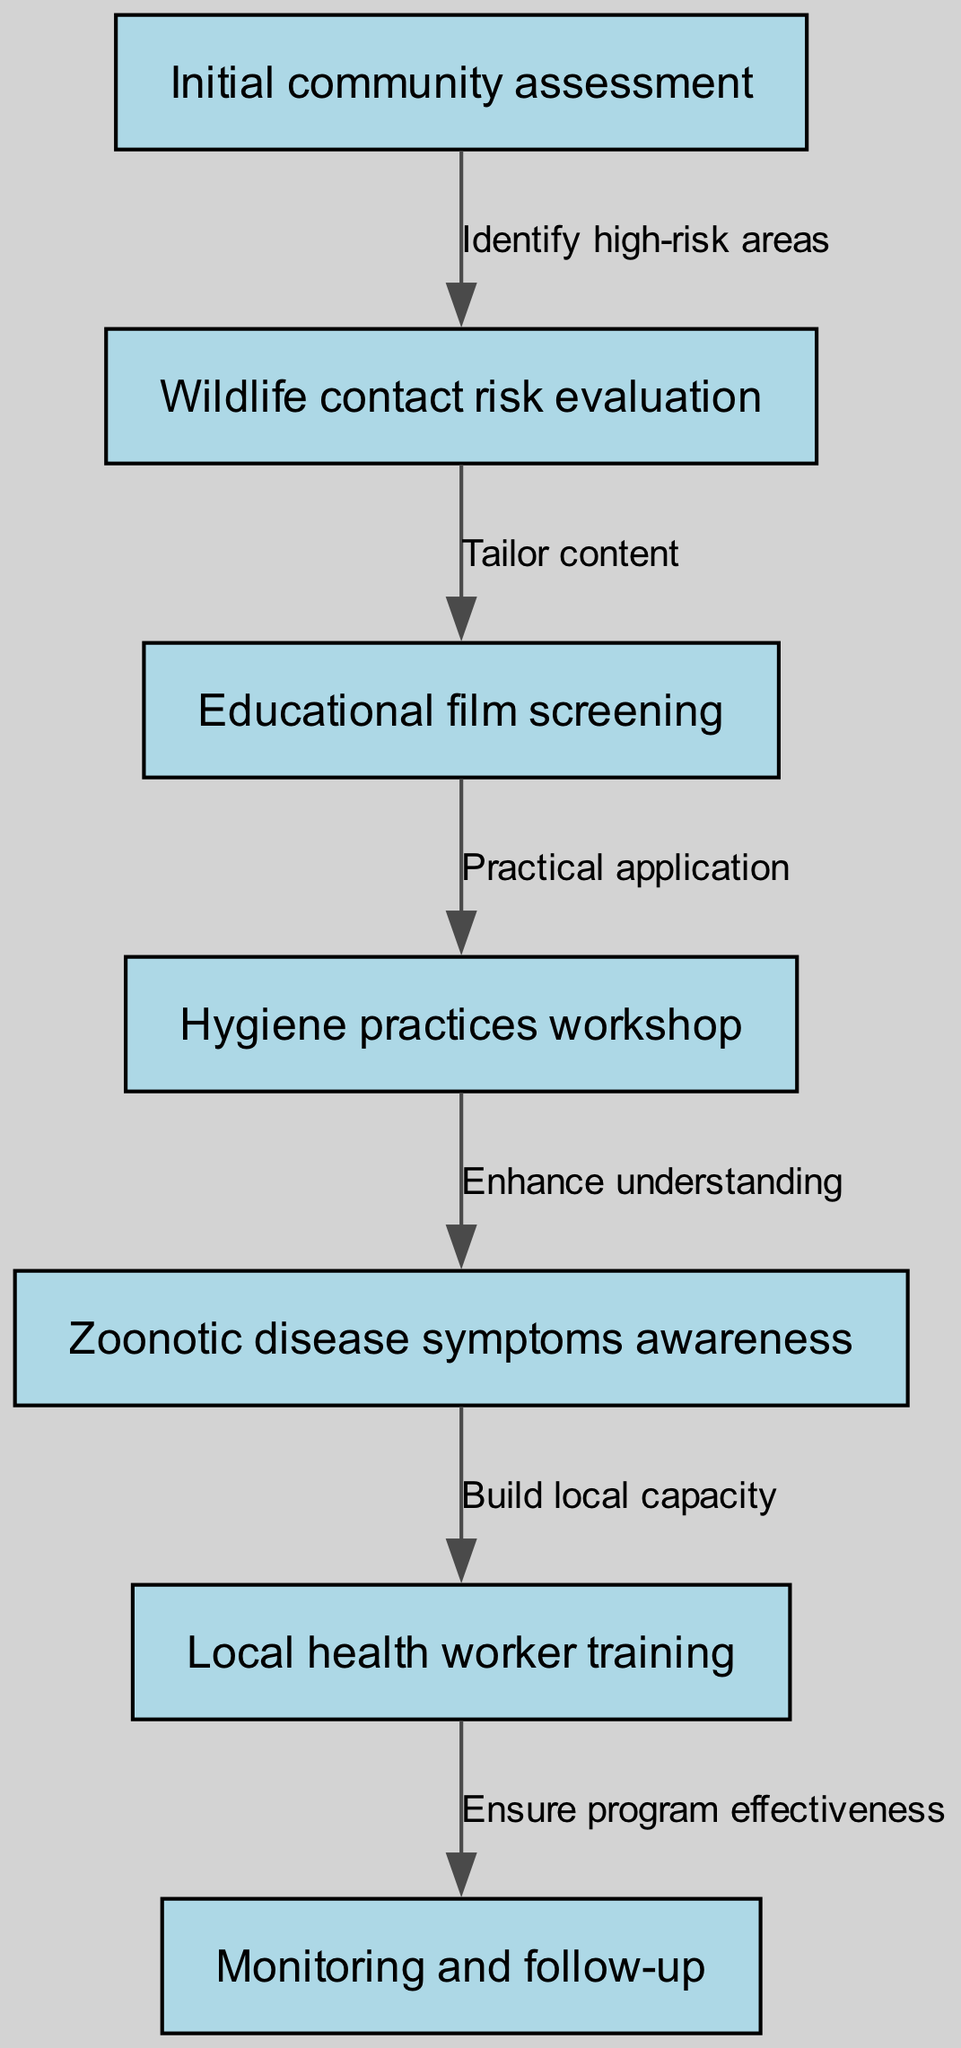What is the first step in the clinical pathway? The first step is represented by the node labeled "Initial community assessment," which is where the program begins.
Answer: Initial community assessment How many nodes are present in the diagram? Counting all unique nodes in the diagram, there are a total of 7 nodes, each representing a step in the pathway.
Answer: 7 What is the relationship between "Education film screening" and "Hygiene practices workshop"? The relationship is indicated by the edge that connects these nodes, which states "Practical application," showing that the workshop follows the screening for practical skill development.
Answer: Practical application Which node comes after "Zoonotic disease symptoms awareness"? The node that follows "Zoonotic disease symptoms awareness" is labeled "Local health worker training," marking a transition to building capacity in the community.
Answer: Local health worker training What edge connects "Wildlife contact risk evaluation" to "Educational film screening"? The edge that connects these two nodes is labeled "Tailor content," indicating that the risk evaluation informs the content of the educational film.
Answer: Tailor content What is the last step in the pathway? The last step is represented by the node labeled "Monitoring and follow-up," indicating that after training local health workers, the program concludes with a follow-up phase.
Answer: Monitoring and follow-up What does "Ensure program effectiveness" signify in this context? "Ensure program effectiveness" is indicated as the outcome of the training of local health workers, which reflects the aim to evaluate and enhance the outreach program.
Answer: Ensure program effectiveness What theme connects all the nodes in the diagram? Each node in the diagram is interconnected around the theme of zoonotic disease prevention in forest-dwelling populations, focusing on community health outreach.
Answer: Zoonotic disease prevention 